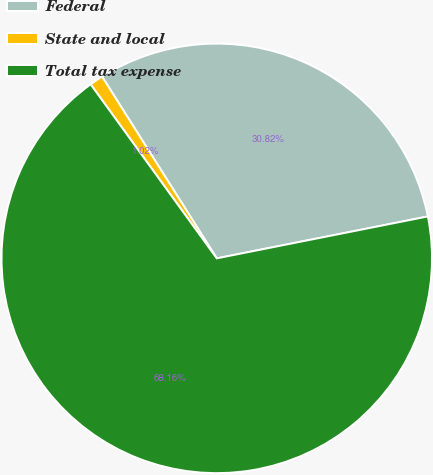<chart> <loc_0><loc_0><loc_500><loc_500><pie_chart><fcel>Federal<fcel>State and local<fcel>Total tax expense<nl><fcel>30.82%<fcel>1.02%<fcel>68.17%<nl></chart> 